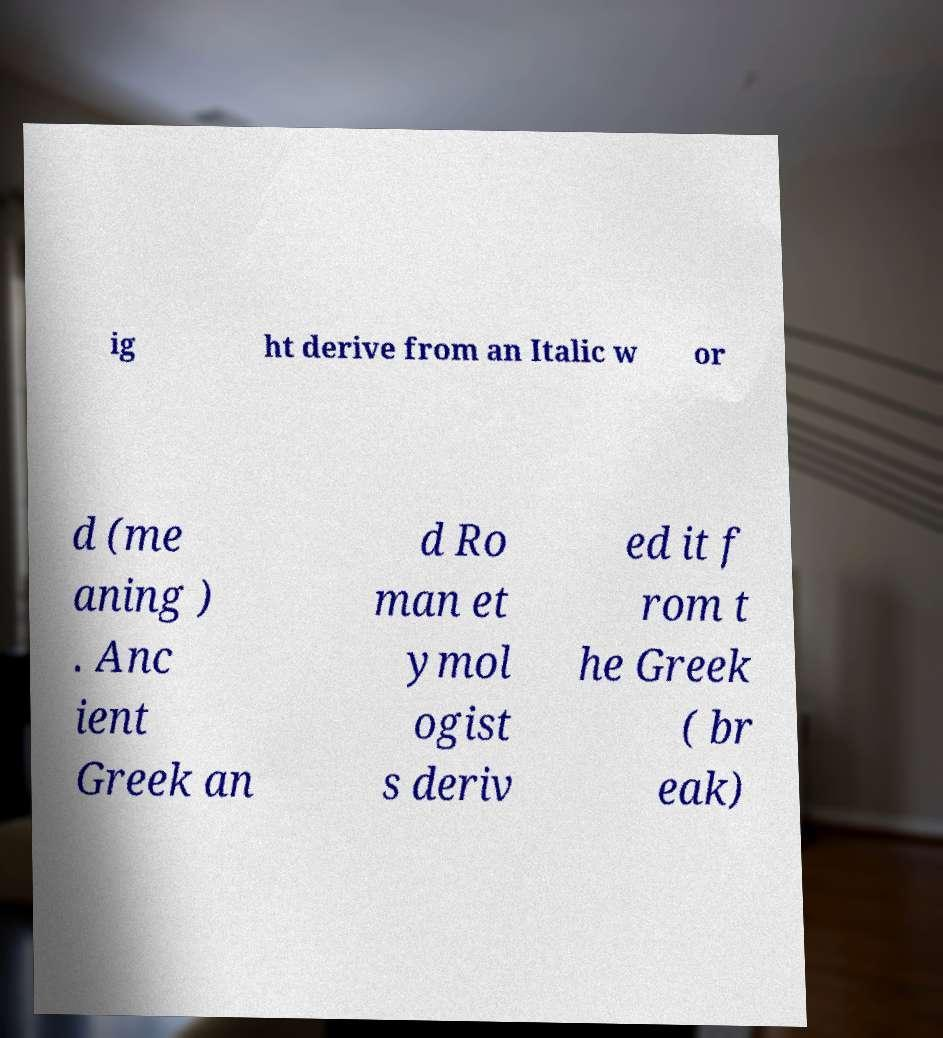Please identify and transcribe the text found in this image. ig ht derive from an Italic w or d (me aning ) . Anc ient Greek an d Ro man et ymol ogist s deriv ed it f rom t he Greek ( br eak) 